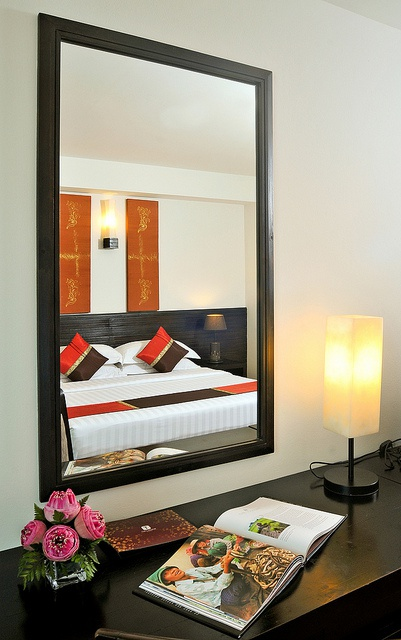Describe the objects in this image and their specific colors. I can see bed in darkgray, lightgray, black, and gray tones, book in darkgray, lightgray, black, and gray tones, potted plant in darkgray, black, brown, and darkgreen tones, and vase in black and darkgray tones in this image. 